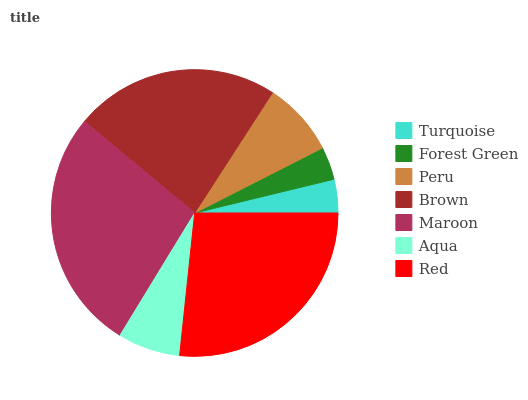Is Forest Green the minimum?
Answer yes or no. Yes. Is Maroon the maximum?
Answer yes or no. Yes. Is Peru the minimum?
Answer yes or no. No. Is Peru the maximum?
Answer yes or no. No. Is Peru greater than Forest Green?
Answer yes or no. Yes. Is Forest Green less than Peru?
Answer yes or no. Yes. Is Forest Green greater than Peru?
Answer yes or no. No. Is Peru less than Forest Green?
Answer yes or no. No. Is Peru the high median?
Answer yes or no. Yes. Is Peru the low median?
Answer yes or no. Yes. Is Forest Green the high median?
Answer yes or no. No. Is Turquoise the low median?
Answer yes or no. No. 